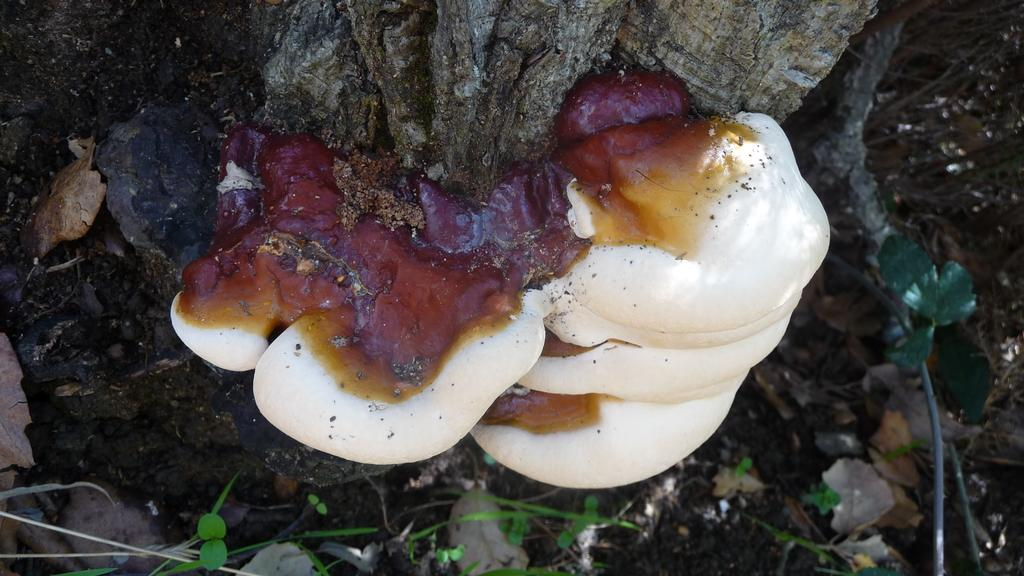What is the main object in the image? There is a tree trunk in the image. What is growing on the tree trunk? There are mushrooms attached to the tree trunk. What other types of vegetation can be seen in the image? There are plants and grass in the image. What type of work is being done on the side of the tree trunk? There is no indication of any work being done on the tree trunk or its side in the image. 